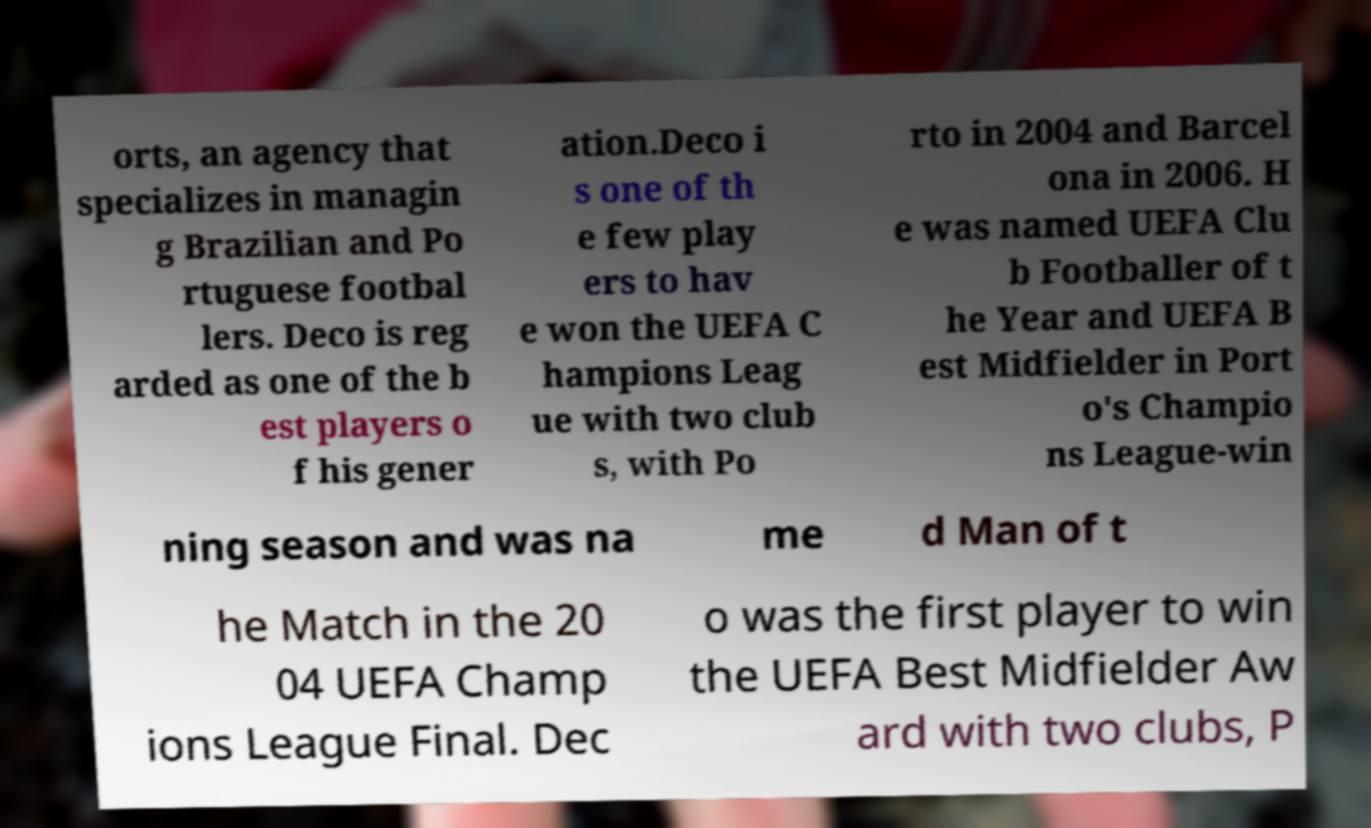Could you extract and type out the text from this image? orts, an agency that specializes in managin g Brazilian and Po rtuguese footbal lers. Deco is reg arded as one of the b est players o f his gener ation.Deco i s one of th e few play ers to hav e won the UEFA C hampions Leag ue with two club s, with Po rto in 2004 and Barcel ona in 2006. H e was named UEFA Clu b Footballer of t he Year and UEFA B est Midfielder in Port o's Champio ns League-win ning season and was na me d Man of t he Match in the 20 04 UEFA Champ ions League Final. Dec o was the first player to win the UEFA Best Midfielder Aw ard with two clubs, P 